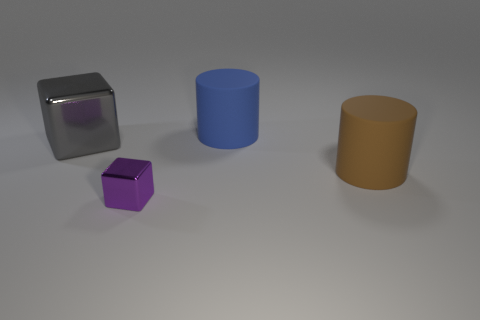Is there any other thing that is the same size as the purple thing?
Your answer should be compact. No. Does the small thing on the left side of the large brown cylinder have the same color as the thing that is to the right of the large blue matte thing?
Your answer should be very brief. No. What color is the thing that is behind the big brown cylinder and in front of the blue matte cylinder?
Ensure brevity in your answer.  Gray. What number of purple shiny objects are the same size as the gray cube?
Offer a very short reply. 0. There is a large rubber object behind the block that is behind the purple thing; what shape is it?
Offer a terse response. Cylinder. What is the shape of the metal object in front of the big object that is to the left of the matte cylinder behind the big brown matte cylinder?
Ensure brevity in your answer.  Cube. How many other metallic objects have the same shape as the tiny metallic thing?
Offer a terse response. 1. There is a cube that is to the left of the small block; what number of purple metal things are behind it?
Provide a short and direct response. 0. What number of matte objects are either purple cubes or big gray blocks?
Your answer should be compact. 0. Is there a brown cylinder that has the same material as the brown thing?
Your answer should be compact. No. 